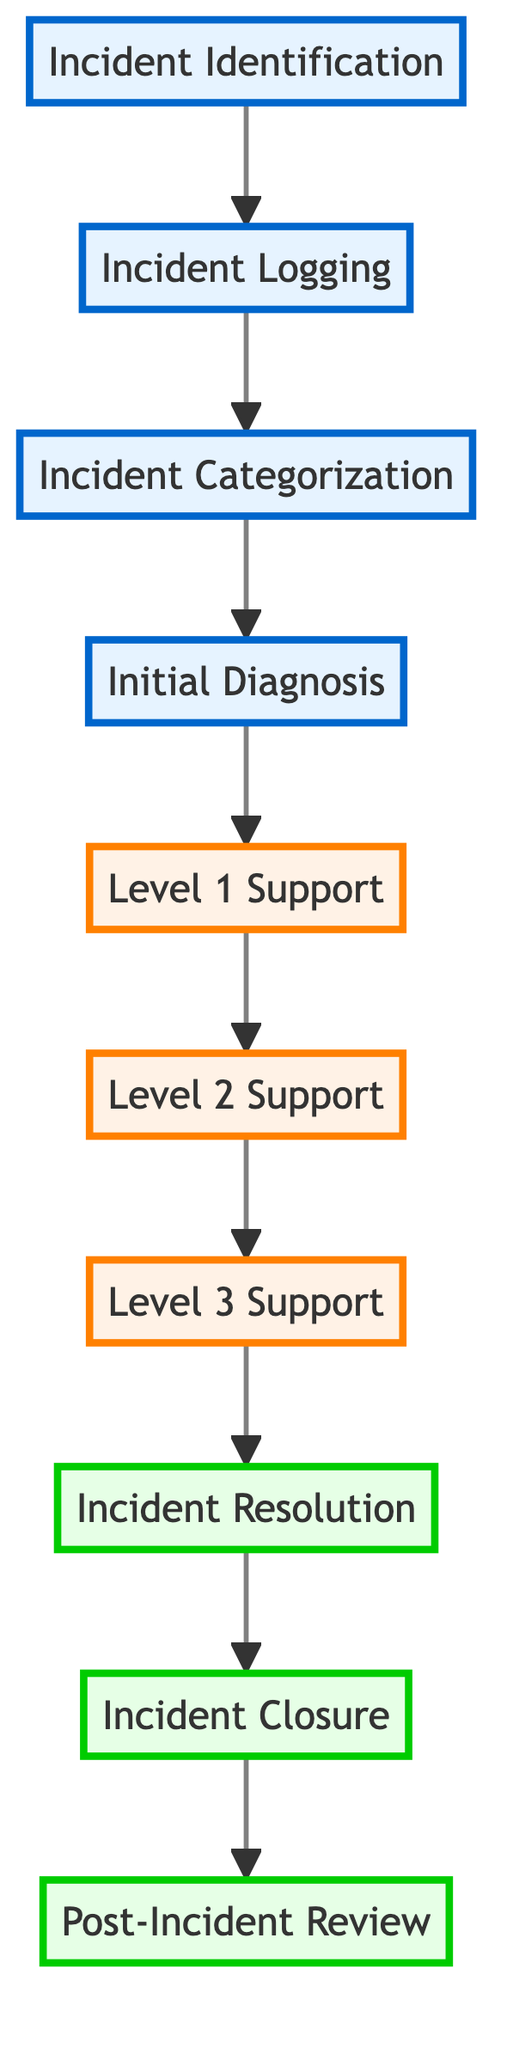What's the first step in the incident management process? The diagram lists "Incident Identification" as the first step at the bottom of the flow chart, indicating that this is the starting point of the process.
Answer: Incident Identification How many escalation levels are there in the incident management process? The diagram shows three escalation levels before reaching incident resolution. They are Level 1 Support, Level 2 Support, and Level 3 Support.
Answer: Three What follows after the initial diagnosis in the process? After "Initial Diagnosis," the flow chart indicates an arrow pointing to "Incident Escalation - Level 1 Support," showing that this is the next step in the sequence.
Answer: Incident Escalation - Level 1 Support In which level is the incident formally closed? The diagram indicates that "Incident Closure" is listed as the final step in the process after "Incident Resolution," making it the closure phase.
Answer: Incident Closure What is the highest level of escalation in the incident management process? The flow chart identifies "Incident Escalation - Level 3 Support" as the highest escalation level, located near the top just before incident resolution.
Answer: Incident Escalation - Level 3 Support Which step directly precedes the post-incident review? The diagram shows "Incident Closure" as the step that comes right before "Post-Incident Review," indicating the sequence of actions.
Answer: Incident Closure What is the purpose of the "Post-Incident Review"? The "Post-Incident Review" is described in the diagram as a step to conduct a review for identifying the root cause and areas for improvement.
Answer: Identify root cause and areas for improvement Which element is the last step in the incident management flow? The flow chart indicates "Post-Incident Review" is the last step, as it appears at the top of the diagram.
Answer: Post-Incident Review 